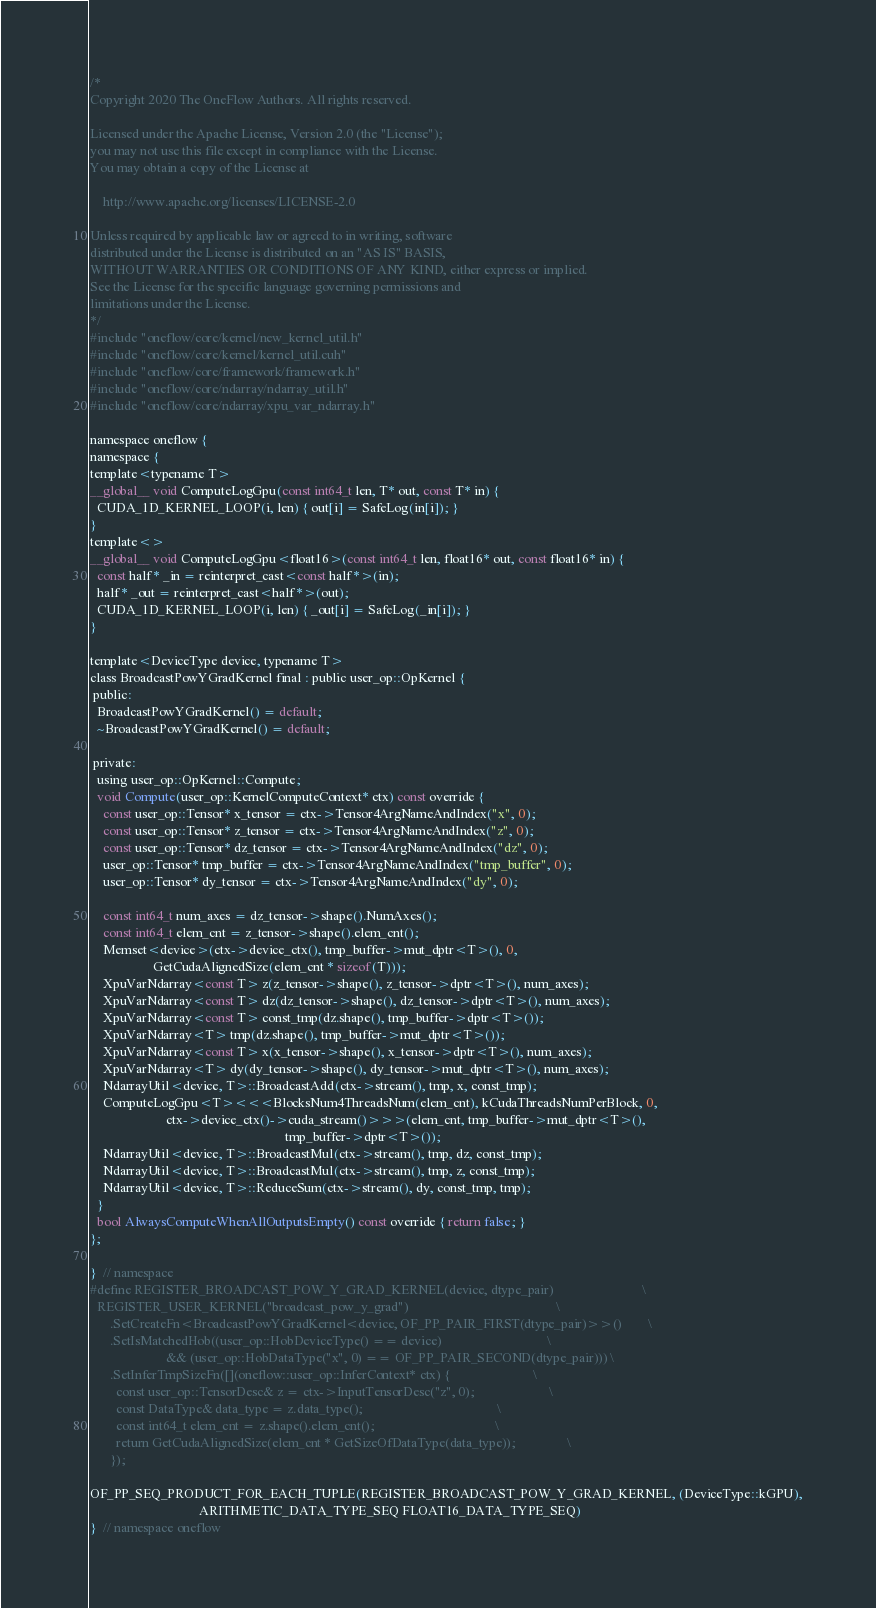<code> <loc_0><loc_0><loc_500><loc_500><_Cuda_>/*
Copyright 2020 The OneFlow Authors. All rights reserved.

Licensed under the Apache License, Version 2.0 (the "License");
you may not use this file except in compliance with the License.
You may obtain a copy of the License at

    http://www.apache.org/licenses/LICENSE-2.0

Unless required by applicable law or agreed to in writing, software
distributed under the License is distributed on an "AS IS" BASIS,
WITHOUT WARRANTIES OR CONDITIONS OF ANY KIND, either express or implied.
See the License for the specific language governing permissions and
limitations under the License.
*/
#include "oneflow/core/kernel/new_kernel_util.h"
#include "oneflow/core/kernel/kernel_util.cuh"
#include "oneflow/core/framework/framework.h"
#include "oneflow/core/ndarray/ndarray_util.h"
#include "oneflow/core/ndarray/xpu_var_ndarray.h"

namespace oneflow {
namespace {
template<typename T>
__global__ void ComputeLogGpu(const int64_t len, T* out, const T* in) {
  CUDA_1D_KERNEL_LOOP(i, len) { out[i] = SafeLog(in[i]); }
}
template<>
__global__ void ComputeLogGpu<float16>(const int64_t len, float16* out, const float16* in) {
  const half* _in = reinterpret_cast<const half*>(in);
  half* _out = reinterpret_cast<half*>(out);
  CUDA_1D_KERNEL_LOOP(i, len) { _out[i] = SafeLog(_in[i]); }
}

template<DeviceType device, typename T>
class BroadcastPowYGradKernel final : public user_op::OpKernel {
 public:
  BroadcastPowYGradKernel() = default;
  ~BroadcastPowYGradKernel() = default;

 private:
  using user_op::OpKernel::Compute;
  void Compute(user_op::KernelComputeContext* ctx) const override {
    const user_op::Tensor* x_tensor = ctx->Tensor4ArgNameAndIndex("x", 0);
    const user_op::Tensor* z_tensor = ctx->Tensor4ArgNameAndIndex("z", 0);
    const user_op::Tensor* dz_tensor = ctx->Tensor4ArgNameAndIndex("dz", 0);
    user_op::Tensor* tmp_buffer = ctx->Tensor4ArgNameAndIndex("tmp_buffer", 0);
    user_op::Tensor* dy_tensor = ctx->Tensor4ArgNameAndIndex("dy", 0);

    const int64_t num_axes = dz_tensor->shape().NumAxes();
    const int64_t elem_cnt = z_tensor->shape().elem_cnt();
    Memset<device>(ctx->device_ctx(), tmp_buffer->mut_dptr<T>(), 0,
                   GetCudaAlignedSize(elem_cnt * sizeof(T)));
    XpuVarNdarray<const T> z(z_tensor->shape(), z_tensor->dptr<T>(), num_axes);
    XpuVarNdarray<const T> dz(dz_tensor->shape(), dz_tensor->dptr<T>(), num_axes);
    XpuVarNdarray<const T> const_tmp(dz.shape(), tmp_buffer->dptr<T>());
    XpuVarNdarray<T> tmp(dz.shape(), tmp_buffer->mut_dptr<T>());
    XpuVarNdarray<const T> x(x_tensor->shape(), x_tensor->dptr<T>(), num_axes);
    XpuVarNdarray<T> dy(dy_tensor->shape(), dy_tensor->mut_dptr<T>(), num_axes);
    NdarrayUtil<device, T>::BroadcastAdd(ctx->stream(), tmp, x, const_tmp);
    ComputeLogGpu<T><<<BlocksNum4ThreadsNum(elem_cnt), kCudaThreadsNumPerBlock, 0,
                       ctx->device_ctx()->cuda_stream()>>>(elem_cnt, tmp_buffer->mut_dptr<T>(),
                                                           tmp_buffer->dptr<T>());
    NdarrayUtil<device, T>::BroadcastMul(ctx->stream(), tmp, dz, const_tmp);
    NdarrayUtil<device, T>::BroadcastMul(ctx->stream(), tmp, z, const_tmp);
    NdarrayUtil<device, T>::ReduceSum(ctx->stream(), dy, const_tmp, tmp);
  }
  bool AlwaysComputeWhenAllOutputsEmpty() const override { return false; }
};

}  // namespace
#define REGISTER_BROADCAST_POW_Y_GRAD_KERNEL(device, dtype_pair)                           \
  REGISTER_USER_KERNEL("broadcast_pow_y_grad")                                             \
      .SetCreateFn<BroadcastPowYGradKernel<device, OF_PP_PAIR_FIRST(dtype_pair)>>()        \
      .SetIsMatchedHob((user_op::HobDeviceType() == device)                                \
                       && (user_op::HobDataType("x", 0) == OF_PP_PAIR_SECOND(dtype_pair))) \
      .SetInferTmpSizeFn([](oneflow::user_op::InferContext* ctx) {                         \
        const user_op::TensorDesc& z = ctx->InputTensorDesc("z", 0);                       \
        const DataType& data_type = z.data_type();                                         \
        const int64_t elem_cnt = z.shape().elem_cnt();                                     \
        return GetCudaAlignedSize(elem_cnt * GetSizeOfDataType(data_type));                \
      });

OF_PP_SEQ_PRODUCT_FOR_EACH_TUPLE(REGISTER_BROADCAST_POW_Y_GRAD_KERNEL, (DeviceType::kGPU),
                                 ARITHMETIC_DATA_TYPE_SEQ FLOAT16_DATA_TYPE_SEQ)
}  // namespace oneflow
</code> 